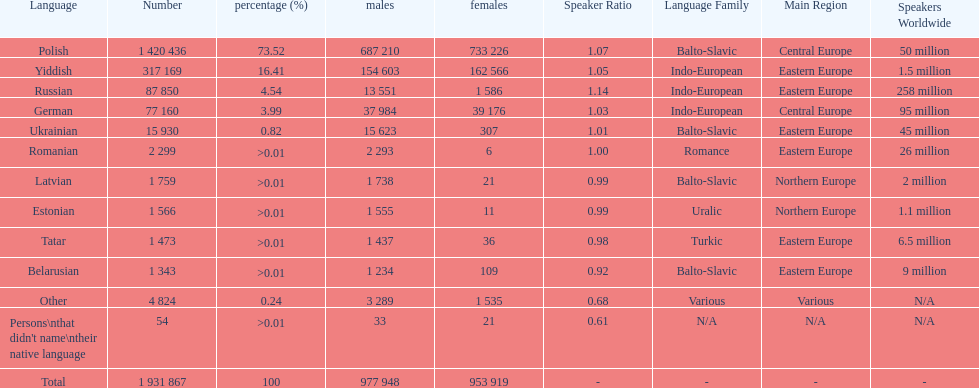What is the highest percentage of speakers other than polish? Yiddish. 